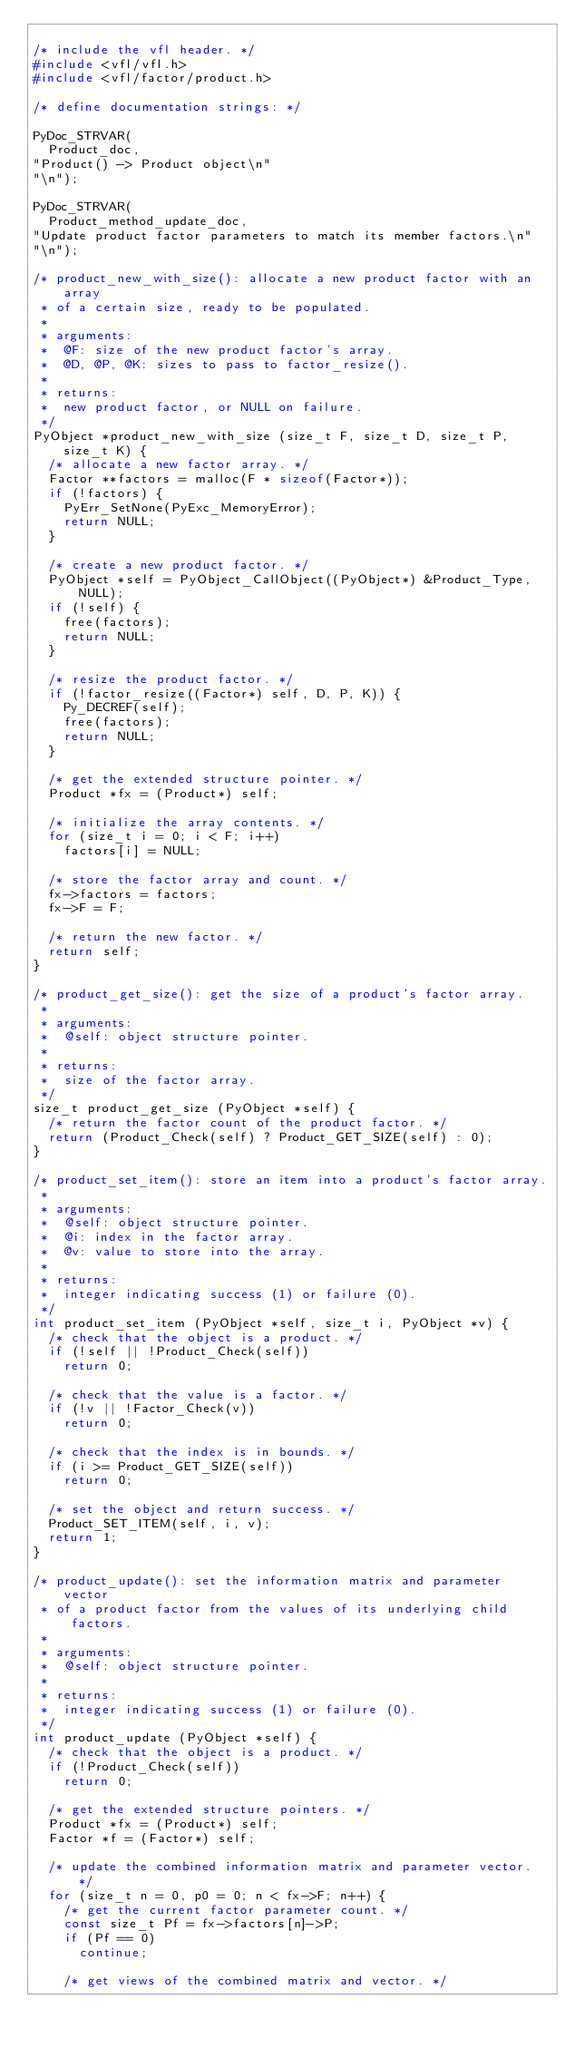Convert code to text. <code><loc_0><loc_0><loc_500><loc_500><_C_>
/* include the vfl header. */
#include <vfl/vfl.h>
#include <vfl/factor/product.h>

/* define documentation strings: */

PyDoc_STRVAR(
  Product_doc,
"Product() -> Product object\n"
"\n");

PyDoc_STRVAR(
  Product_method_update_doc,
"Update product factor parameters to match its member factors.\n"
"\n");

/* product_new_with_size(): allocate a new product factor with an array
 * of a certain size, ready to be populated.
 *
 * arguments:
 *  @F: size of the new product factor's array.
 *  @D, @P, @K: sizes to pass to factor_resize().
 *
 * returns:
 *  new product factor, or NULL on failure.
 */
PyObject *product_new_with_size (size_t F, size_t D, size_t P, size_t K) {
  /* allocate a new factor array. */
  Factor **factors = malloc(F * sizeof(Factor*));
  if (!factors) {
    PyErr_SetNone(PyExc_MemoryError);
    return NULL;
  }

  /* create a new product factor. */
  PyObject *self = PyObject_CallObject((PyObject*) &Product_Type, NULL);
  if (!self) {
    free(factors);
    return NULL;
  }

  /* resize the product factor. */
  if (!factor_resize((Factor*) self, D, P, K)) {
    Py_DECREF(self);
    free(factors);
    return NULL;
  }

  /* get the extended structure pointer. */
  Product *fx = (Product*) self;

  /* initialize the array contents. */
  for (size_t i = 0; i < F; i++)
    factors[i] = NULL;

  /* store the factor array and count. */
  fx->factors = factors;
  fx->F = F;

  /* return the new factor. */
  return self;
}

/* product_get_size(): get the size of a product's factor array.
 *
 * arguments:
 *  @self: object structure pointer.
 *
 * returns:
 *  size of the factor array.
 */
size_t product_get_size (PyObject *self) {
  /* return the factor count of the product factor. */
  return (Product_Check(self) ? Product_GET_SIZE(self) : 0);
}

/* product_set_item(): store an item into a product's factor array.
 *
 * arguments:
 *  @self: object structure pointer.
 *  @i: index in the factor array.
 *  @v: value to store into the array.
 *
 * returns:
 *  integer indicating success (1) or failure (0).
 */
int product_set_item (PyObject *self, size_t i, PyObject *v) {
  /* check that the object is a product. */
  if (!self || !Product_Check(self))
    return 0;

  /* check that the value is a factor. */
  if (!v || !Factor_Check(v))
    return 0;

  /* check that the index is in bounds. */
  if (i >= Product_GET_SIZE(self))
    return 0;

  /* set the object and return success. */
  Product_SET_ITEM(self, i, v);
  return 1;
}

/* product_update(): set the information matrix and parameter vector
 * of a product factor from the values of its underlying child factors.
 *
 * arguments:
 *  @self: object structure pointer.
 *
 * returns:
 *  integer indicating success (1) or failure (0).
 */
int product_update (PyObject *self) {
  /* check that the object is a product. */
  if (!Product_Check(self))
    return 0;

  /* get the extended structure pointers. */
  Product *fx = (Product*) self;
  Factor *f = (Factor*) self;

  /* update the combined information matrix and parameter vector. */
  for (size_t n = 0, p0 = 0; n < fx->F; n++) {
    /* get the current factor parameter count. */
    const size_t Pf = fx->factors[n]->P;
    if (Pf == 0)
      continue;

    /* get views of the combined matrix and vector. */</code> 